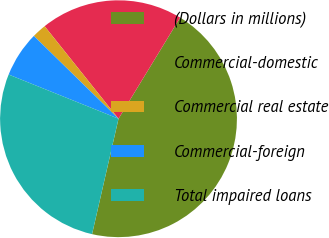Convert chart to OTSL. <chart><loc_0><loc_0><loc_500><loc_500><pie_chart><fcel>(Dollars in millions)<fcel>Commercial-domestic<fcel>Commercial real estate<fcel>Commercial-foreign<fcel>Total impaired loans<nl><fcel>44.88%<fcel>19.44%<fcel>1.95%<fcel>6.24%<fcel>27.5%<nl></chart> 